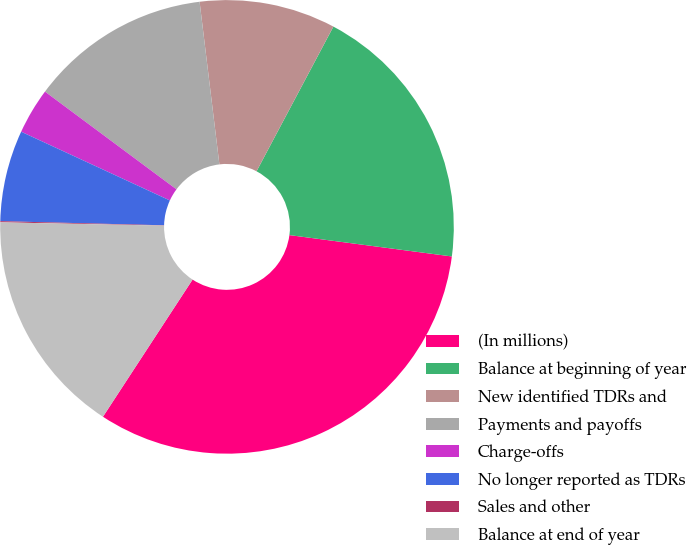Convert chart. <chart><loc_0><loc_0><loc_500><loc_500><pie_chart><fcel>(In millions)<fcel>Balance at beginning of year<fcel>New identified TDRs and<fcel>Payments and payoffs<fcel>Charge-offs<fcel>No longer reported as TDRs<fcel>Sales and other<fcel>Balance at end of year<nl><fcel>32.13%<fcel>19.31%<fcel>9.7%<fcel>12.9%<fcel>3.28%<fcel>6.49%<fcel>0.08%<fcel>16.11%<nl></chart> 